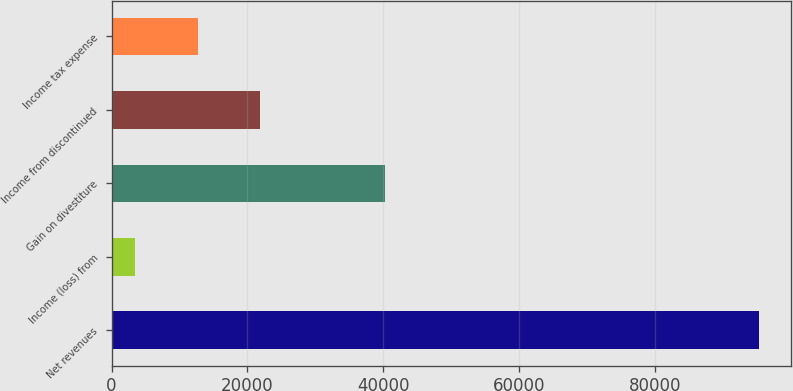Convert chart to OTSL. <chart><loc_0><loc_0><loc_500><loc_500><bar_chart><fcel>Net revenues<fcel>Income (loss) from<fcel>Gain on divestiture<fcel>Income from discontinued<fcel>Income tax expense<nl><fcel>95226<fcel>3472<fcel>40173.6<fcel>21822.8<fcel>12647.4<nl></chart> 